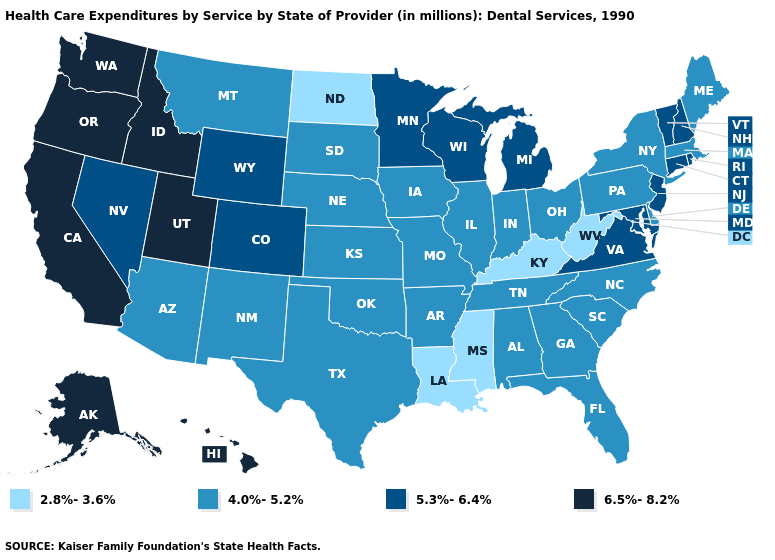What is the highest value in states that border Oklahoma?
Be succinct. 5.3%-6.4%. Among the states that border Colorado , which have the lowest value?
Keep it brief. Arizona, Kansas, Nebraska, New Mexico, Oklahoma. What is the value of North Carolina?
Write a very short answer. 4.0%-5.2%. Which states hav the highest value in the West?
Answer briefly. Alaska, California, Hawaii, Idaho, Oregon, Utah, Washington. What is the lowest value in the MidWest?
Write a very short answer. 2.8%-3.6%. Name the states that have a value in the range 6.5%-8.2%?
Quick response, please. Alaska, California, Hawaii, Idaho, Oregon, Utah, Washington. Does the map have missing data?
Keep it brief. No. What is the highest value in the West ?
Short answer required. 6.5%-8.2%. What is the lowest value in states that border Louisiana?
Concise answer only. 2.8%-3.6%. Does the map have missing data?
Keep it brief. No. Among the states that border Delaware , which have the lowest value?
Quick response, please. Pennsylvania. Among the states that border Louisiana , does Mississippi have the highest value?
Keep it brief. No. Which states have the lowest value in the USA?
Give a very brief answer. Kentucky, Louisiana, Mississippi, North Dakota, West Virginia. What is the highest value in the USA?
Give a very brief answer. 6.5%-8.2%. What is the highest value in states that border Vermont?
Quick response, please. 5.3%-6.4%. 